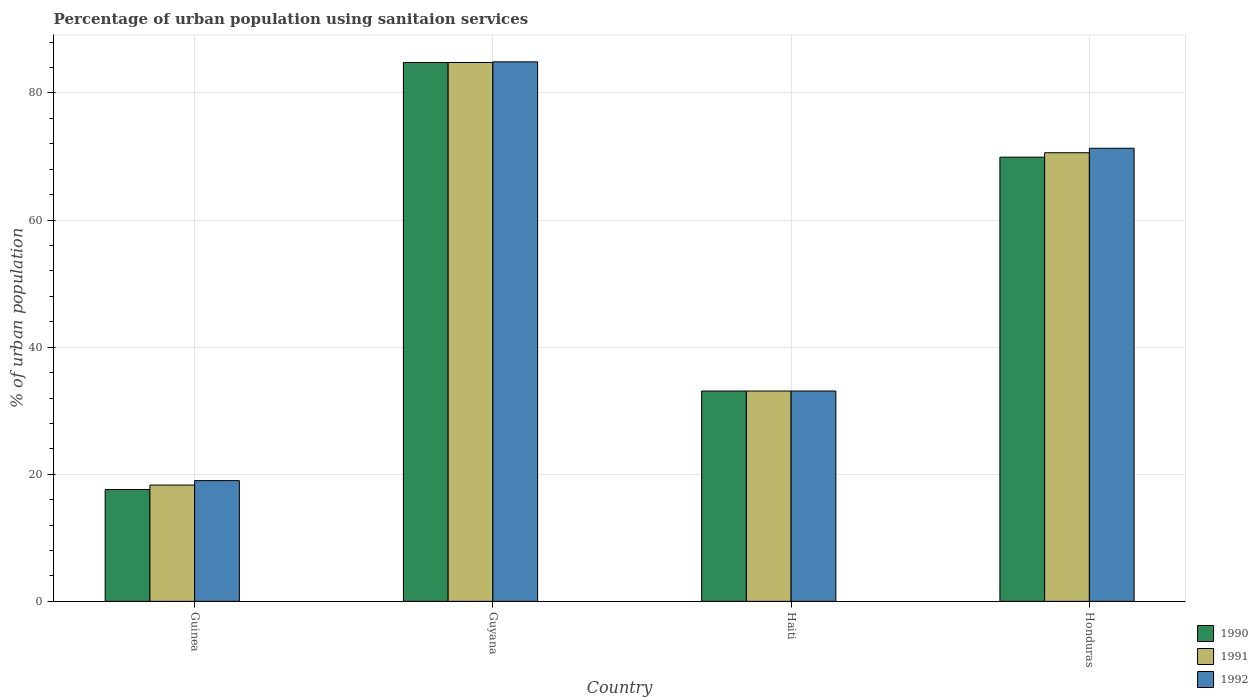How many groups of bars are there?
Ensure brevity in your answer.  4. Are the number of bars on each tick of the X-axis equal?
Offer a very short reply. Yes. What is the label of the 2nd group of bars from the left?
Make the answer very short. Guyana. What is the percentage of urban population using sanitaion services in 1991 in Guinea?
Make the answer very short. 18.3. Across all countries, what is the maximum percentage of urban population using sanitaion services in 1990?
Give a very brief answer. 84.8. In which country was the percentage of urban population using sanitaion services in 1991 maximum?
Your answer should be compact. Guyana. In which country was the percentage of urban population using sanitaion services in 1992 minimum?
Give a very brief answer. Guinea. What is the total percentage of urban population using sanitaion services in 1991 in the graph?
Ensure brevity in your answer.  206.8. What is the difference between the percentage of urban population using sanitaion services in 1990 in Guinea and that in Guyana?
Make the answer very short. -67.2. What is the difference between the percentage of urban population using sanitaion services in 1990 in Guinea and the percentage of urban population using sanitaion services in 1991 in Honduras?
Your answer should be very brief. -53. What is the average percentage of urban population using sanitaion services in 1992 per country?
Offer a terse response. 52.08. What is the difference between the percentage of urban population using sanitaion services of/in 1990 and percentage of urban population using sanitaion services of/in 1992 in Guinea?
Provide a short and direct response. -1.4. In how many countries, is the percentage of urban population using sanitaion services in 1992 greater than 20 %?
Provide a succinct answer. 3. What is the ratio of the percentage of urban population using sanitaion services in 1992 in Haiti to that in Honduras?
Ensure brevity in your answer.  0.46. Is the percentage of urban population using sanitaion services in 1990 in Guinea less than that in Honduras?
Make the answer very short. Yes. Is the difference between the percentage of urban population using sanitaion services in 1990 in Guinea and Honduras greater than the difference between the percentage of urban population using sanitaion services in 1992 in Guinea and Honduras?
Offer a terse response. No. What is the difference between the highest and the second highest percentage of urban population using sanitaion services in 1990?
Provide a short and direct response. -51.7. What is the difference between the highest and the lowest percentage of urban population using sanitaion services in 1991?
Offer a terse response. 66.5. Is the sum of the percentage of urban population using sanitaion services in 1992 in Guyana and Haiti greater than the maximum percentage of urban population using sanitaion services in 1991 across all countries?
Offer a very short reply. Yes. What does the 2nd bar from the right in Haiti represents?
Keep it short and to the point. 1991. Is it the case that in every country, the sum of the percentage of urban population using sanitaion services in 1992 and percentage of urban population using sanitaion services in 1990 is greater than the percentage of urban population using sanitaion services in 1991?
Your response must be concise. Yes. Does the graph contain any zero values?
Offer a very short reply. No. Where does the legend appear in the graph?
Ensure brevity in your answer.  Bottom right. How many legend labels are there?
Provide a succinct answer. 3. How are the legend labels stacked?
Offer a very short reply. Vertical. What is the title of the graph?
Make the answer very short. Percentage of urban population using sanitaion services. What is the label or title of the X-axis?
Provide a short and direct response. Country. What is the label or title of the Y-axis?
Offer a very short reply. % of urban population. What is the % of urban population in 1990 in Guinea?
Your answer should be compact. 17.6. What is the % of urban population in 1991 in Guinea?
Make the answer very short. 18.3. What is the % of urban population of 1992 in Guinea?
Give a very brief answer. 19. What is the % of urban population of 1990 in Guyana?
Offer a terse response. 84.8. What is the % of urban population of 1991 in Guyana?
Your answer should be compact. 84.8. What is the % of urban population in 1992 in Guyana?
Provide a short and direct response. 84.9. What is the % of urban population of 1990 in Haiti?
Keep it short and to the point. 33.1. What is the % of urban population in 1991 in Haiti?
Ensure brevity in your answer.  33.1. What is the % of urban population of 1992 in Haiti?
Provide a succinct answer. 33.1. What is the % of urban population of 1990 in Honduras?
Give a very brief answer. 69.9. What is the % of urban population in 1991 in Honduras?
Provide a succinct answer. 70.6. What is the % of urban population of 1992 in Honduras?
Provide a short and direct response. 71.3. Across all countries, what is the maximum % of urban population in 1990?
Your response must be concise. 84.8. Across all countries, what is the maximum % of urban population in 1991?
Make the answer very short. 84.8. Across all countries, what is the maximum % of urban population of 1992?
Your answer should be compact. 84.9. What is the total % of urban population of 1990 in the graph?
Keep it short and to the point. 205.4. What is the total % of urban population in 1991 in the graph?
Keep it short and to the point. 206.8. What is the total % of urban population in 1992 in the graph?
Your answer should be compact. 208.3. What is the difference between the % of urban population in 1990 in Guinea and that in Guyana?
Your answer should be very brief. -67.2. What is the difference between the % of urban population of 1991 in Guinea and that in Guyana?
Your answer should be very brief. -66.5. What is the difference between the % of urban population in 1992 in Guinea and that in Guyana?
Your answer should be compact. -65.9. What is the difference between the % of urban population in 1990 in Guinea and that in Haiti?
Offer a terse response. -15.5. What is the difference between the % of urban population of 1991 in Guinea and that in Haiti?
Your answer should be very brief. -14.8. What is the difference between the % of urban population of 1992 in Guinea and that in Haiti?
Provide a succinct answer. -14.1. What is the difference between the % of urban population of 1990 in Guinea and that in Honduras?
Ensure brevity in your answer.  -52.3. What is the difference between the % of urban population of 1991 in Guinea and that in Honduras?
Your answer should be compact. -52.3. What is the difference between the % of urban population in 1992 in Guinea and that in Honduras?
Your response must be concise. -52.3. What is the difference between the % of urban population of 1990 in Guyana and that in Haiti?
Your response must be concise. 51.7. What is the difference between the % of urban population in 1991 in Guyana and that in Haiti?
Provide a short and direct response. 51.7. What is the difference between the % of urban population of 1992 in Guyana and that in Haiti?
Offer a very short reply. 51.8. What is the difference between the % of urban population in 1990 in Guyana and that in Honduras?
Keep it short and to the point. 14.9. What is the difference between the % of urban population in 1991 in Guyana and that in Honduras?
Give a very brief answer. 14.2. What is the difference between the % of urban population in 1992 in Guyana and that in Honduras?
Your answer should be very brief. 13.6. What is the difference between the % of urban population of 1990 in Haiti and that in Honduras?
Offer a terse response. -36.8. What is the difference between the % of urban population in 1991 in Haiti and that in Honduras?
Your answer should be compact. -37.5. What is the difference between the % of urban population in 1992 in Haiti and that in Honduras?
Ensure brevity in your answer.  -38.2. What is the difference between the % of urban population of 1990 in Guinea and the % of urban population of 1991 in Guyana?
Keep it short and to the point. -67.2. What is the difference between the % of urban population in 1990 in Guinea and the % of urban population in 1992 in Guyana?
Offer a terse response. -67.3. What is the difference between the % of urban population in 1991 in Guinea and the % of urban population in 1992 in Guyana?
Offer a terse response. -66.6. What is the difference between the % of urban population of 1990 in Guinea and the % of urban population of 1991 in Haiti?
Provide a succinct answer. -15.5. What is the difference between the % of urban population of 1990 in Guinea and the % of urban population of 1992 in Haiti?
Make the answer very short. -15.5. What is the difference between the % of urban population in 1991 in Guinea and the % of urban population in 1992 in Haiti?
Keep it short and to the point. -14.8. What is the difference between the % of urban population of 1990 in Guinea and the % of urban population of 1991 in Honduras?
Your response must be concise. -53. What is the difference between the % of urban population of 1990 in Guinea and the % of urban population of 1992 in Honduras?
Provide a short and direct response. -53.7. What is the difference between the % of urban population in 1991 in Guinea and the % of urban population in 1992 in Honduras?
Offer a very short reply. -53. What is the difference between the % of urban population in 1990 in Guyana and the % of urban population in 1991 in Haiti?
Your answer should be compact. 51.7. What is the difference between the % of urban population of 1990 in Guyana and the % of urban population of 1992 in Haiti?
Give a very brief answer. 51.7. What is the difference between the % of urban population of 1991 in Guyana and the % of urban population of 1992 in Haiti?
Your answer should be very brief. 51.7. What is the difference between the % of urban population of 1990 in Guyana and the % of urban population of 1992 in Honduras?
Ensure brevity in your answer.  13.5. What is the difference between the % of urban population of 1991 in Guyana and the % of urban population of 1992 in Honduras?
Keep it short and to the point. 13.5. What is the difference between the % of urban population of 1990 in Haiti and the % of urban population of 1991 in Honduras?
Keep it short and to the point. -37.5. What is the difference between the % of urban population of 1990 in Haiti and the % of urban population of 1992 in Honduras?
Ensure brevity in your answer.  -38.2. What is the difference between the % of urban population of 1991 in Haiti and the % of urban population of 1992 in Honduras?
Provide a short and direct response. -38.2. What is the average % of urban population of 1990 per country?
Make the answer very short. 51.35. What is the average % of urban population of 1991 per country?
Make the answer very short. 51.7. What is the average % of urban population in 1992 per country?
Provide a short and direct response. 52.08. What is the difference between the % of urban population of 1991 and % of urban population of 1992 in Guinea?
Provide a succinct answer. -0.7. What is the difference between the % of urban population in 1991 and % of urban population in 1992 in Haiti?
Make the answer very short. 0. What is the difference between the % of urban population of 1990 and % of urban population of 1991 in Honduras?
Ensure brevity in your answer.  -0.7. What is the difference between the % of urban population of 1990 and % of urban population of 1992 in Honduras?
Your answer should be very brief. -1.4. What is the ratio of the % of urban population in 1990 in Guinea to that in Guyana?
Ensure brevity in your answer.  0.21. What is the ratio of the % of urban population of 1991 in Guinea to that in Guyana?
Make the answer very short. 0.22. What is the ratio of the % of urban population in 1992 in Guinea to that in Guyana?
Keep it short and to the point. 0.22. What is the ratio of the % of urban population of 1990 in Guinea to that in Haiti?
Your answer should be compact. 0.53. What is the ratio of the % of urban population of 1991 in Guinea to that in Haiti?
Give a very brief answer. 0.55. What is the ratio of the % of urban population in 1992 in Guinea to that in Haiti?
Give a very brief answer. 0.57. What is the ratio of the % of urban population of 1990 in Guinea to that in Honduras?
Give a very brief answer. 0.25. What is the ratio of the % of urban population of 1991 in Guinea to that in Honduras?
Provide a succinct answer. 0.26. What is the ratio of the % of urban population in 1992 in Guinea to that in Honduras?
Your answer should be compact. 0.27. What is the ratio of the % of urban population in 1990 in Guyana to that in Haiti?
Provide a succinct answer. 2.56. What is the ratio of the % of urban population in 1991 in Guyana to that in Haiti?
Your answer should be very brief. 2.56. What is the ratio of the % of urban population in 1992 in Guyana to that in Haiti?
Your response must be concise. 2.56. What is the ratio of the % of urban population of 1990 in Guyana to that in Honduras?
Give a very brief answer. 1.21. What is the ratio of the % of urban population of 1991 in Guyana to that in Honduras?
Offer a terse response. 1.2. What is the ratio of the % of urban population in 1992 in Guyana to that in Honduras?
Give a very brief answer. 1.19. What is the ratio of the % of urban population in 1990 in Haiti to that in Honduras?
Keep it short and to the point. 0.47. What is the ratio of the % of urban population in 1991 in Haiti to that in Honduras?
Ensure brevity in your answer.  0.47. What is the ratio of the % of urban population of 1992 in Haiti to that in Honduras?
Make the answer very short. 0.46. What is the difference between the highest and the second highest % of urban population of 1991?
Offer a very short reply. 14.2. What is the difference between the highest and the second highest % of urban population of 1992?
Make the answer very short. 13.6. What is the difference between the highest and the lowest % of urban population of 1990?
Make the answer very short. 67.2. What is the difference between the highest and the lowest % of urban population in 1991?
Your answer should be compact. 66.5. What is the difference between the highest and the lowest % of urban population in 1992?
Provide a short and direct response. 65.9. 